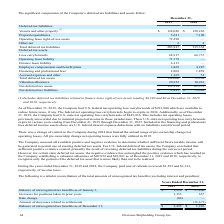According to Overseas Shipholding Group's financial document, For which years did U.S. Internal Revenue Service completed exams on the Company's U.S. federal income tax returns? Based on the financial document, the answer is 2012 - 2015. Also, can you calculate: What is the change in Balance of unrecognized tax benefits as of January 1, from Years Ended December 31, 2018 to 2019? Based on the calculation: 1,226-37,240, the result is -36014. This is based on the information: "e of unrecognized tax benefits as of January 1, $ 1,226 $ 37,240 ecognized tax benefits as of January 1, $ 1,226 $ 37,240..." The key data points involved are: 1,226, 37,240. Also, can you calculate: What is the average Balance of unrecognized tax benefits as of January 1, for Years Ended December 31, 2018 to 2019? To answer this question, I need to perform calculations using the financial data. The calculation is: (1,226+37,240) / 2, which equals 19233. This is based on the information: "e of unrecognized tax benefits as of January 1, $ 1,226 $ 37,240 ecognized tax benefits as of January 1, $ 1,226 $ 37,240..." The key data points involved are: 1,226, 37,240. Additionally, In which year was Increases for positions taken in prior years less than 1,000? According to the financial document, 2018. The relevant text states: "2019 2018..." Also, What was the Rate change in 2019 and 2018 respectively? The document shows two values: (84) and 0. From the document: "Rate change (84) — 2019 2018..." Also, What was the Balance of unrecognized tax benefits as of December 31, 2019? According to the financial document, $2,495. The relevant text states: "of unrecognized tax benefits as of December 31, $ 2,495 $ 1,226..." 